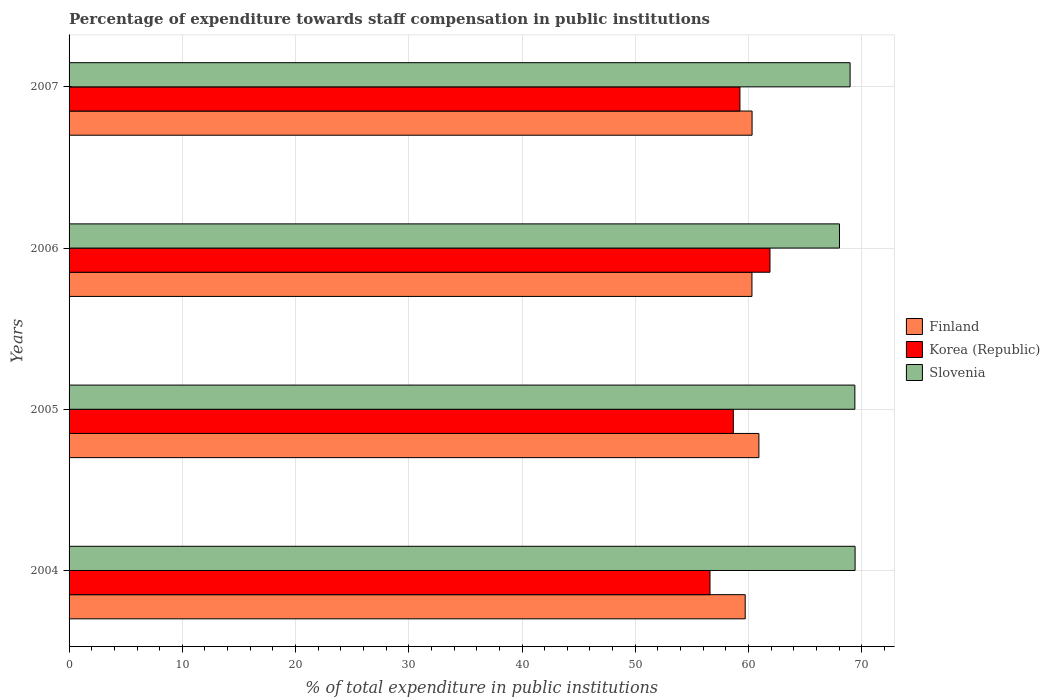How many different coloured bars are there?
Ensure brevity in your answer.  3. How many groups of bars are there?
Offer a terse response. 4. Are the number of bars per tick equal to the number of legend labels?
Your response must be concise. Yes. How many bars are there on the 3rd tick from the bottom?
Your answer should be very brief. 3. In how many cases, is the number of bars for a given year not equal to the number of legend labels?
Offer a terse response. 0. What is the percentage of expenditure towards staff compensation in Finland in 2004?
Your answer should be compact. 59.71. Across all years, what is the maximum percentage of expenditure towards staff compensation in Slovenia?
Offer a very short reply. 69.42. Across all years, what is the minimum percentage of expenditure towards staff compensation in Korea (Republic)?
Ensure brevity in your answer.  56.6. In which year was the percentage of expenditure towards staff compensation in Korea (Republic) maximum?
Offer a very short reply. 2006. In which year was the percentage of expenditure towards staff compensation in Korea (Republic) minimum?
Keep it short and to the point. 2004. What is the total percentage of expenditure towards staff compensation in Finland in the graph?
Your answer should be very brief. 241.26. What is the difference between the percentage of expenditure towards staff compensation in Korea (Republic) in 2006 and that in 2007?
Your response must be concise. 2.65. What is the difference between the percentage of expenditure towards staff compensation in Finland in 2006 and the percentage of expenditure towards staff compensation in Slovenia in 2007?
Offer a terse response. -8.67. What is the average percentage of expenditure towards staff compensation in Slovenia per year?
Keep it short and to the point. 68.96. In the year 2004, what is the difference between the percentage of expenditure towards staff compensation in Slovenia and percentage of expenditure towards staff compensation in Korea (Republic)?
Make the answer very short. 12.81. In how many years, is the percentage of expenditure towards staff compensation in Finland greater than 18 %?
Keep it short and to the point. 4. What is the ratio of the percentage of expenditure towards staff compensation in Finland in 2004 to that in 2005?
Provide a short and direct response. 0.98. Is the percentage of expenditure towards staff compensation in Slovenia in 2004 less than that in 2005?
Ensure brevity in your answer.  No. What is the difference between the highest and the second highest percentage of expenditure towards staff compensation in Korea (Republic)?
Provide a short and direct response. 2.65. What is the difference between the highest and the lowest percentage of expenditure towards staff compensation in Korea (Republic)?
Provide a succinct answer. 5.3. Is the sum of the percentage of expenditure towards staff compensation in Korea (Republic) in 2004 and 2006 greater than the maximum percentage of expenditure towards staff compensation in Finland across all years?
Keep it short and to the point. Yes. What does the 3rd bar from the bottom in 2007 represents?
Offer a terse response. Slovenia. Are the values on the major ticks of X-axis written in scientific E-notation?
Make the answer very short. No. Does the graph contain any zero values?
Your answer should be very brief. No. What is the title of the graph?
Keep it short and to the point. Percentage of expenditure towards staff compensation in public institutions. What is the label or title of the X-axis?
Provide a succinct answer. % of total expenditure in public institutions. What is the label or title of the Y-axis?
Offer a very short reply. Years. What is the % of total expenditure in public institutions in Finland in 2004?
Your answer should be compact. 59.71. What is the % of total expenditure in public institutions in Korea (Republic) in 2004?
Make the answer very short. 56.6. What is the % of total expenditure in public institutions of Slovenia in 2004?
Your answer should be very brief. 69.42. What is the % of total expenditure in public institutions of Finland in 2005?
Your answer should be compact. 60.92. What is the % of total expenditure in public institutions of Korea (Republic) in 2005?
Ensure brevity in your answer.  58.66. What is the % of total expenditure in public institutions in Slovenia in 2005?
Provide a succinct answer. 69.39. What is the % of total expenditure in public institutions of Finland in 2006?
Provide a succinct answer. 60.31. What is the % of total expenditure in public institutions of Korea (Republic) in 2006?
Provide a short and direct response. 61.9. What is the % of total expenditure in public institutions in Slovenia in 2006?
Your answer should be very brief. 68.04. What is the % of total expenditure in public institutions in Finland in 2007?
Your response must be concise. 60.32. What is the % of total expenditure in public institutions of Korea (Republic) in 2007?
Keep it short and to the point. 59.25. What is the % of total expenditure in public institutions in Slovenia in 2007?
Give a very brief answer. 68.97. Across all years, what is the maximum % of total expenditure in public institutions in Finland?
Your answer should be very brief. 60.92. Across all years, what is the maximum % of total expenditure in public institutions of Korea (Republic)?
Your answer should be compact. 61.9. Across all years, what is the maximum % of total expenditure in public institutions in Slovenia?
Make the answer very short. 69.42. Across all years, what is the minimum % of total expenditure in public institutions in Finland?
Your response must be concise. 59.71. Across all years, what is the minimum % of total expenditure in public institutions in Korea (Republic)?
Ensure brevity in your answer.  56.6. Across all years, what is the minimum % of total expenditure in public institutions of Slovenia?
Provide a short and direct response. 68.04. What is the total % of total expenditure in public institutions of Finland in the graph?
Ensure brevity in your answer.  241.26. What is the total % of total expenditure in public institutions in Korea (Republic) in the graph?
Offer a very short reply. 236.41. What is the total % of total expenditure in public institutions in Slovenia in the graph?
Your response must be concise. 275.82. What is the difference between the % of total expenditure in public institutions in Finland in 2004 and that in 2005?
Ensure brevity in your answer.  -1.21. What is the difference between the % of total expenditure in public institutions in Korea (Republic) in 2004 and that in 2005?
Provide a short and direct response. -2.06. What is the difference between the % of total expenditure in public institutions in Slovenia in 2004 and that in 2005?
Your answer should be compact. 0.02. What is the difference between the % of total expenditure in public institutions in Finland in 2004 and that in 2006?
Offer a very short reply. -0.6. What is the difference between the % of total expenditure in public institutions of Korea (Republic) in 2004 and that in 2006?
Offer a terse response. -5.3. What is the difference between the % of total expenditure in public institutions in Slovenia in 2004 and that in 2006?
Make the answer very short. 1.38. What is the difference between the % of total expenditure in public institutions of Finland in 2004 and that in 2007?
Provide a succinct answer. -0.61. What is the difference between the % of total expenditure in public institutions of Korea (Republic) in 2004 and that in 2007?
Ensure brevity in your answer.  -2.64. What is the difference between the % of total expenditure in public institutions of Slovenia in 2004 and that in 2007?
Offer a very short reply. 0.44. What is the difference between the % of total expenditure in public institutions of Finland in 2005 and that in 2006?
Offer a terse response. 0.61. What is the difference between the % of total expenditure in public institutions in Korea (Republic) in 2005 and that in 2006?
Make the answer very short. -3.24. What is the difference between the % of total expenditure in public institutions of Slovenia in 2005 and that in 2006?
Offer a very short reply. 1.36. What is the difference between the % of total expenditure in public institutions of Finland in 2005 and that in 2007?
Provide a succinct answer. 0.6. What is the difference between the % of total expenditure in public institutions of Korea (Republic) in 2005 and that in 2007?
Ensure brevity in your answer.  -0.58. What is the difference between the % of total expenditure in public institutions in Slovenia in 2005 and that in 2007?
Give a very brief answer. 0.42. What is the difference between the % of total expenditure in public institutions of Finland in 2006 and that in 2007?
Keep it short and to the point. -0.01. What is the difference between the % of total expenditure in public institutions in Korea (Republic) in 2006 and that in 2007?
Give a very brief answer. 2.65. What is the difference between the % of total expenditure in public institutions in Slovenia in 2006 and that in 2007?
Your response must be concise. -0.94. What is the difference between the % of total expenditure in public institutions of Finland in 2004 and the % of total expenditure in public institutions of Korea (Republic) in 2005?
Ensure brevity in your answer.  1.05. What is the difference between the % of total expenditure in public institutions in Finland in 2004 and the % of total expenditure in public institutions in Slovenia in 2005?
Make the answer very short. -9.68. What is the difference between the % of total expenditure in public institutions of Korea (Republic) in 2004 and the % of total expenditure in public institutions of Slovenia in 2005?
Offer a terse response. -12.79. What is the difference between the % of total expenditure in public institutions in Finland in 2004 and the % of total expenditure in public institutions in Korea (Republic) in 2006?
Your answer should be very brief. -2.19. What is the difference between the % of total expenditure in public institutions in Finland in 2004 and the % of total expenditure in public institutions in Slovenia in 2006?
Offer a terse response. -8.33. What is the difference between the % of total expenditure in public institutions in Korea (Republic) in 2004 and the % of total expenditure in public institutions in Slovenia in 2006?
Your answer should be compact. -11.43. What is the difference between the % of total expenditure in public institutions of Finland in 2004 and the % of total expenditure in public institutions of Korea (Republic) in 2007?
Your answer should be very brief. 0.47. What is the difference between the % of total expenditure in public institutions in Finland in 2004 and the % of total expenditure in public institutions in Slovenia in 2007?
Your answer should be very brief. -9.26. What is the difference between the % of total expenditure in public institutions of Korea (Republic) in 2004 and the % of total expenditure in public institutions of Slovenia in 2007?
Make the answer very short. -12.37. What is the difference between the % of total expenditure in public institutions of Finland in 2005 and the % of total expenditure in public institutions of Korea (Republic) in 2006?
Ensure brevity in your answer.  -0.98. What is the difference between the % of total expenditure in public institutions of Finland in 2005 and the % of total expenditure in public institutions of Slovenia in 2006?
Your answer should be very brief. -7.12. What is the difference between the % of total expenditure in public institutions of Korea (Republic) in 2005 and the % of total expenditure in public institutions of Slovenia in 2006?
Offer a very short reply. -9.37. What is the difference between the % of total expenditure in public institutions in Finland in 2005 and the % of total expenditure in public institutions in Korea (Republic) in 2007?
Your answer should be very brief. 1.68. What is the difference between the % of total expenditure in public institutions of Finland in 2005 and the % of total expenditure in public institutions of Slovenia in 2007?
Keep it short and to the point. -8.05. What is the difference between the % of total expenditure in public institutions in Korea (Republic) in 2005 and the % of total expenditure in public institutions in Slovenia in 2007?
Your answer should be very brief. -10.31. What is the difference between the % of total expenditure in public institutions of Finland in 2006 and the % of total expenditure in public institutions of Korea (Republic) in 2007?
Offer a very short reply. 1.06. What is the difference between the % of total expenditure in public institutions of Finland in 2006 and the % of total expenditure in public institutions of Slovenia in 2007?
Keep it short and to the point. -8.67. What is the difference between the % of total expenditure in public institutions in Korea (Republic) in 2006 and the % of total expenditure in public institutions in Slovenia in 2007?
Your answer should be compact. -7.08. What is the average % of total expenditure in public institutions of Finland per year?
Keep it short and to the point. 60.31. What is the average % of total expenditure in public institutions of Korea (Republic) per year?
Make the answer very short. 59.1. What is the average % of total expenditure in public institutions in Slovenia per year?
Give a very brief answer. 68.96. In the year 2004, what is the difference between the % of total expenditure in public institutions of Finland and % of total expenditure in public institutions of Korea (Republic)?
Keep it short and to the point. 3.11. In the year 2004, what is the difference between the % of total expenditure in public institutions of Finland and % of total expenditure in public institutions of Slovenia?
Your answer should be very brief. -9.7. In the year 2004, what is the difference between the % of total expenditure in public institutions in Korea (Republic) and % of total expenditure in public institutions in Slovenia?
Keep it short and to the point. -12.81. In the year 2005, what is the difference between the % of total expenditure in public institutions of Finland and % of total expenditure in public institutions of Korea (Republic)?
Your answer should be compact. 2.26. In the year 2005, what is the difference between the % of total expenditure in public institutions of Finland and % of total expenditure in public institutions of Slovenia?
Offer a terse response. -8.47. In the year 2005, what is the difference between the % of total expenditure in public institutions in Korea (Republic) and % of total expenditure in public institutions in Slovenia?
Offer a very short reply. -10.73. In the year 2006, what is the difference between the % of total expenditure in public institutions in Finland and % of total expenditure in public institutions in Korea (Republic)?
Offer a very short reply. -1.59. In the year 2006, what is the difference between the % of total expenditure in public institutions of Finland and % of total expenditure in public institutions of Slovenia?
Your answer should be very brief. -7.73. In the year 2006, what is the difference between the % of total expenditure in public institutions of Korea (Republic) and % of total expenditure in public institutions of Slovenia?
Your response must be concise. -6.14. In the year 2007, what is the difference between the % of total expenditure in public institutions in Finland and % of total expenditure in public institutions in Korea (Republic)?
Your answer should be very brief. 1.07. In the year 2007, what is the difference between the % of total expenditure in public institutions of Finland and % of total expenditure in public institutions of Slovenia?
Your response must be concise. -8.66. In the year 2007, what is the difference between the % of total expenditure in public institutions of Korea (Republic) and % of total expenditure in public institutions of Slovenia?
Make the answer very short. -9.73. What is the ratio of the % of total expenditure in public institutions of Finland in 2004 to that in 2005?
Make the answer very short. 0.98. What is the ratio of the % of total expenditure in public institutions in Korea (Republic) in 2004 to that in 2005?
Ensure brevity in your answer.  0.96. What is the ratio of the % of total expenditure in public institutions of Finland in 2004 to that in 2006?
Give a very brief answer. 0.99. What is the ratio of the % of total expenditure in public institutions of Korea (Republic) in 2004 to that in 2006?
Your answer should be compact. 0.91. What is the ratio of the % of total expenditure in public institutions of Slovenia in 2004 to that in 2006?
Give a very brief answer. 1.02. What is the ratio of the % of total expenditure in public institutions of Finland in 2004 to that in 2007?
Your answer should be compact. 0.99. What is the ratio of the % of total expenditure in public institutions of Korea (Republic) in 2004 to that in 2007?
Provide a succinct answer. 0.96. What is the ratio of the % of total expenditure in public institutions in Slovenia in 2004 to that in 2007?
Offer a very short reply. 1.01. What is the ratio of the % of total expenditure in public institutions of Finland in 2005 to that in 2006?
Offer a very short reply. 1.01. What is the ratio of the % of total expenditure in public institutions of Korea (Republic) in 2005 to that in 2006?
Ensure brevity in your answer.  0.95. What is the ratio of the % of total expenditure in public institutions of Slovenia in 2005 to that in 2006?
Your answer should be compact. 1.02. What is the ratio of the % of total expenditure in public institutions of Korea (Republic) in 2005 to that in 2007?
Your response must be concise. 0.99. What is the ratio of the % of total expenditure in public institutions in Slovenia in 2005 to that in 2007?
Provide a succinct answer. 1.01. What is the ratio of the % of total expenditure in public institutions of Finland in 2006 to that in 2007?
Make the answer very short. 1. What is the ratio of the % of total expenditure in public institutions in Korea (Republic) in 2006 to that in 2007?
Provide a succinct answer. 1.04. What is the ratio of the % of total expenditure in public institutions in Slovenia in 2006 to that in 2007?
Your answer should be compact. 0.99. What is the difference between the highest and the second highest % of total expenditure in public institutions of Finland?
Provide a succinct answer. 0.6. What is the difference between the highest and the second highest % of total expenditure in public institutions in Korea (Republic)?
Your answer should be very brief. 2.65. What is the difference between the highest and the second highest % of total expenditure in public institutions of Slovenia?
Provide a succinct answer. 0.02. What is the difference between the highest and the lowest % of total expenditure in public institutions in Finland?
Offer a very short reply. 1.21. What is the difference between the highest and the lowest % of total expenditure in public institutions of Korea (Republic)?
Provide a short and direct response. 5.3. What is the difference between the highest and the lowest % of total expenditure in public institutions of Slovenia?
Ensure brevity in your answer.  1.38. 